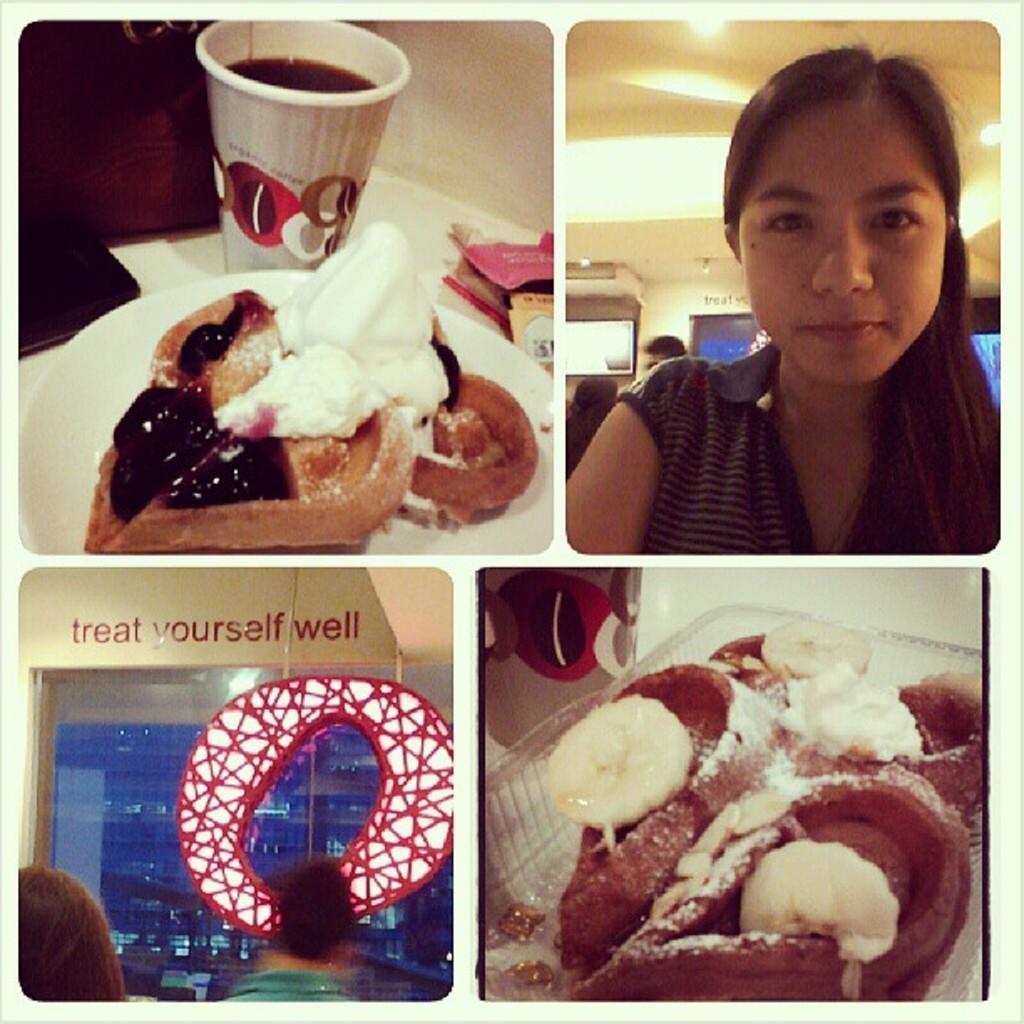In one or two sentences, can you explain what this image depicts? In this image we can see a food item in the plate, here is the cream on it, beside here is the glass on the table, here a woman is standing, at above here is the light. 